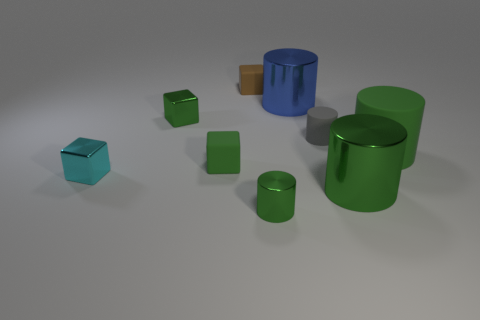Subtract all green cylinders. How many were subtracted if there are1green cylinders left? 2 Subtract all small gray rubber cylinders. How many cylinders are left? 4 Subtract all red cubes. How many green cylinders are left? 3 Subtract all gray cylinders. How many cylinders are left? 4 Subtract 1 cylinders. How many cylinders are left? 4 Subtract all blocks. How many objects are left? 5 Subtract all red blocks. Subtract all green cylinders. How many blocks are left? 4 Subtract 0 blue blocks. How many objects are left? 9 Subtract all green things. Subtract all green metallic cubes. How many objects are left? 3 Add 9 large matte cylinders. How many large matte cylinders are left? 10 